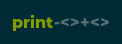Convert code to text. <code><loc_0><loc_0><loc_500><loc_500><_Perl_>print-<>+<></code> 